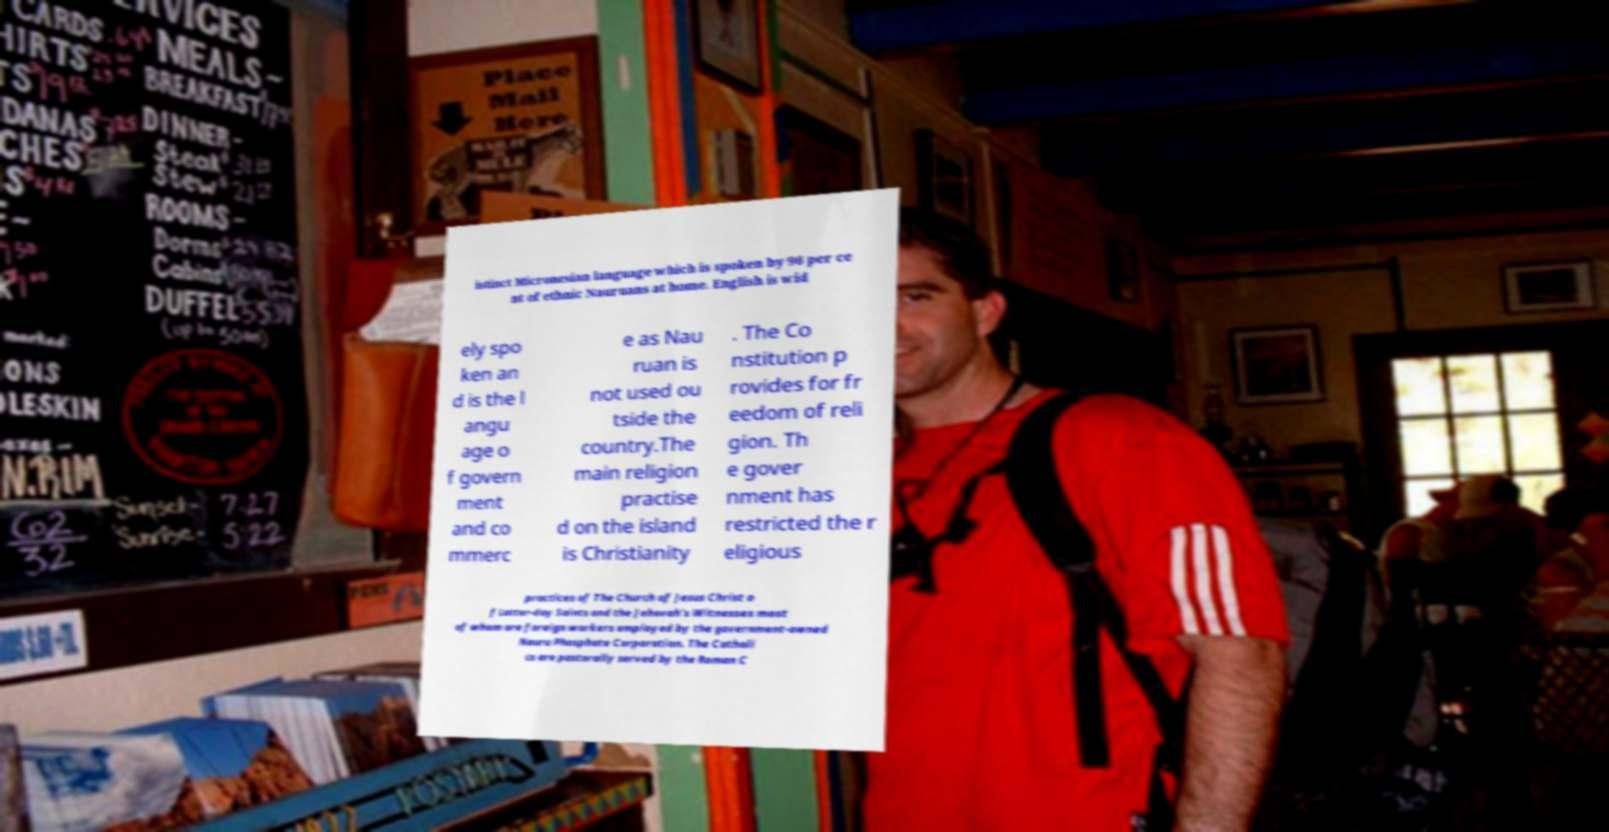I need the written content from this picture converted into text. Can you do that? istinct Micronesian language which is spoken by 96 per ce nt of ethnic Nauruans at home. English is wid ely spo ken an d is the l angu age o f govern ment and co mmerc e as Nau ruan is not used ou tside the country.The main religion practise d on the island is Christianity . The Co nstitution p rovides for fr eedom of reli gion. Th e gover nment has restricted the r eligious practices of The Church of Jesus Christ o f Latter-day Saints and the Jehovah's Witnesses most of whom are foreign workers employed by the government-owned Nauru Phosphate Corporation. The Catholi cs are pastorally served by the Roman C 